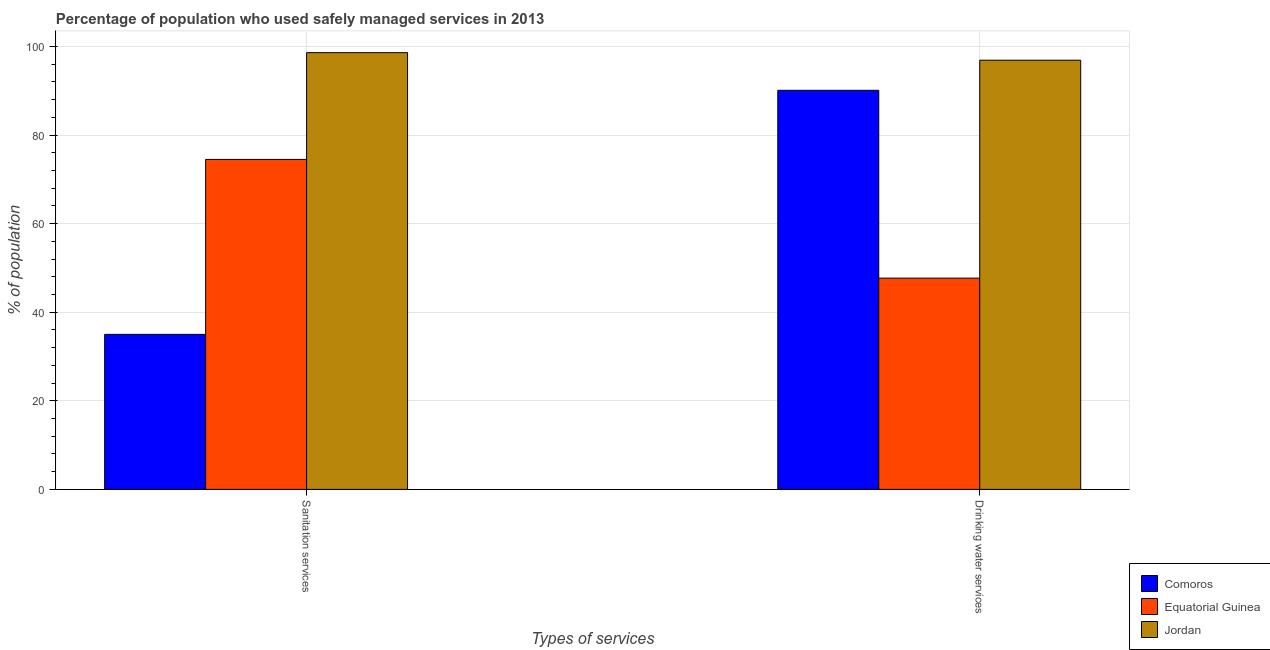How many different coloured bars are there?
Your answer should be very brief. 3. How many groups of bars are there?
Provide a short and direct response. 2. Are the number of bars on each tick of the X-axis equal?
Offer a terse response. Yes. How many bars are there on the 1st tick from the left?
Give a very brief answer. 3. How many bars are there on the 1st tick from the right?
Your answer should be very brief. 3. What is the label of the 1st group of bars from the left?
Your response must be concise. Sanitation services. What is the percentage of population who used sanitation services in Equatorial Guinea?
Your response must be concise. 74.5. Across all countries, what is the maximum percentage of population who used drinking water services?
Keep it short and to the point. 96.9. Across all countries, what is the minimum percentage of population who used drinking water services?
Keep it short and to the point. 47.7. In which country was the percentage of population who used sanitation services maximum?
Provide a succinct answer. Jordan. In which country was the percentage of population who used drinking water services minimum?
Ensure brevity in your answer.  Equatorial Guinea. What is the total percentage of population who used sanitation services in the graph?
Make the answer very short. 208.1. What is the difference between the percentage of population who used sanitation services in Jordan and that in Comoros?
Ensure brevity in your answer.  63.6. What is the difference between the percentage of population who used sanitation services in Jordan and the percentage of population who used drinking water services in Comoros?
Offer a terse response. 8.5. What is the average percentage of population who used sanitation services per country?
Your answer should be compact. 69.37. What is the difference between the percentage of population who used drinking water services and percentage of population who used sanitation services in Jordan?
Give a very brief answer. -1.7. What is the ratio of the percentage of population who used sanitation services in Equatorial Guinea to that in Comoros?
Provide a short and direct response. 2.13. Is the percentage of population who used drinking water services in Jordan less than that in Comoros?
Your response must be concise. No. In how many countries, is the percentage of population who used sanitation services greater than the average percentage of population who used sanitation services taken over all countries?
Offer a very short reply. 2. What does the 3rd bar from the left in Drinking water services represents?
Make the answer very short. Jordan. What does the 1st bar from the right in Drinking water services represents?
Give a very brief answer. Jordan. How many bars are there?
Offer a very short reply. 6. What is the difference between two consecutive major ticks on the Y-axis?
Offer a very short reply. 20. Does the graph contain any zero values?
Your answer should be very brief. No. Does the graph contain grids?
Your response must be concise. Yes. How many legend labels are there?
Provide a short and direct response. 3. How are the legend labels stacked?
Provide a short and direct response. Vertical. What is the title of the graph?
Make the answer very short. Percentage of population who used safely managed services in 2013. Does "Albania" appear as one of the legend labels in the graph?
Provide a short and direct response. No. What is the label or title of the X-axis?
Your answer should be compact. Types of services. What is the label or title of the Y-axis?
Provide a succinct answer. % of population. What is the % of population of Comoros in Sanitation services?
Give a very brief answer. 35. What is the % of population of Equatorial Guinea in Sanitation services?
Offer a terse response. 74.5. What is the % of population of Jordan in Sanitation services?
Offer a very short reply. 98.6. What is the % of population of Comoros in Drinking water services?
Offer a very short reply. 90.1. What is the % of population in Equatorial Guinea in Drinking water services?
Keep it short and to the point. 47.7. What is the % of population in Jordan in Drinking water services?
Give a very brief answer. 96.9. Across all Types of services, what is the maximum % of population of Comoros?
Ensure brevity in your answer.  90.1. Across all Types of services, what is the maximum % of population of Equatorial Guinea?
Your answer should be compact. 74.5. Across all Types of services, what is the maximum % of population of Jordan?
Your response must be concise. 98.6. Across all Types of services, what is the minimum % of population of Equatorial Guinea?
Provide a succinct answer. 47.7. Across all Types of services, what is the minimum % of population of Jordan?
Make the answer very short. 96.9. What is the total % of population of Comoros in the graph?
Ensure brevity in your answer.  125.1. What is the total % of population of Equatorial Guinea in the graph?
Provide a succinct answer. 122.2. What is the total % of population of Jordan in the graph?
Give a very brief answer. 195.5. What is the difference between the % of population in Comoros in Sanitation services and that in Drinking water services?
Offer a terse response. -55.1. What is the difference between the % of population in Equatorial Guinea in Sanitation services and that in Drinking water services?
Offer a terse response. 26.8. What is the difference between the % of population of Comoros in Sanitation services and the % of population of Equatorial Guinea in Drinking water services?
Provide a succinct answer. -12.7. What is the difference between the % of population in Comoros in Sanitation services and the % of population in Jordan in Drinking water services?
Make the answer very short. -61.9. What is the difference between the % of population in Equatorial Guinea in Sanitation services and the % of population in Jordan in Drinking water services?
Provide a succinct answer. -22.4. What is the average % of population of Comoros per Types of services?
Your answer should be very brief. 62.55. What is the average % of population in Equatorial Guinea per Types of services?
Provide a succinct answer. 61.1. What is the average % of population in Jordan per Types of services?
Provide a short and direct response. 97.75. What is the difference between the % of population in Comoros and % of population in Equatorial Guinea in Sanitation services?
Make the answer very short. -39.5. What is the difference between the % of population of Comoros and % of population of Jordan in Sanitation services?
Your answer should be compact. -63.6. What is the difference between the % of population of Equatorial Guinea and % of population of Jordan in Sanitation services?
Provide a succinct answer. -24.1. What is the difference between the % of population of Comoros and % of population of Equatorial Guinea in Drinking water services?
Provide a short and direct response. 42.4. What is the difference between the % of population of Equatorial Guinea and % of population of Jordan in Drinking water services?
Your answer should be very brief. -49.2. What is the ratio of the % of population in Comoros in Sanitation services to that in Drinking water services?
Offer a very short reply. 0.39. What is the ratio of the % of population in Equatorial Guinea in Sanitation services to that in Drinking water services?
Ensure brevity in your answer.  1.56. What is the ratio of the % of population of Jordan in Sanitation services to that in Drinking water services?
Your answer should be compact. 1.02. What is the difference between the highest and the second highest % of population in Comoros?
Make the answer very short. 55.1. What is the difference between the highest and the second highest % of population in Equatorial Guinea?
Keep it short and to the point. 26.8. What is the difference between the highest and the second highest % of population of Jordan?
Your response must be concise. 1.7. What is the difference between the highest and the lowest % of population in Comoros?
Offer a terse response. 55.1. What is the difference between the highest and the lowest % of population of Equatorial Guinea?
Your answer should be compact. 26.8. What is the difference between the highest and the lowest % of population in Jordan?
Offer a very short reply. 1.7. 